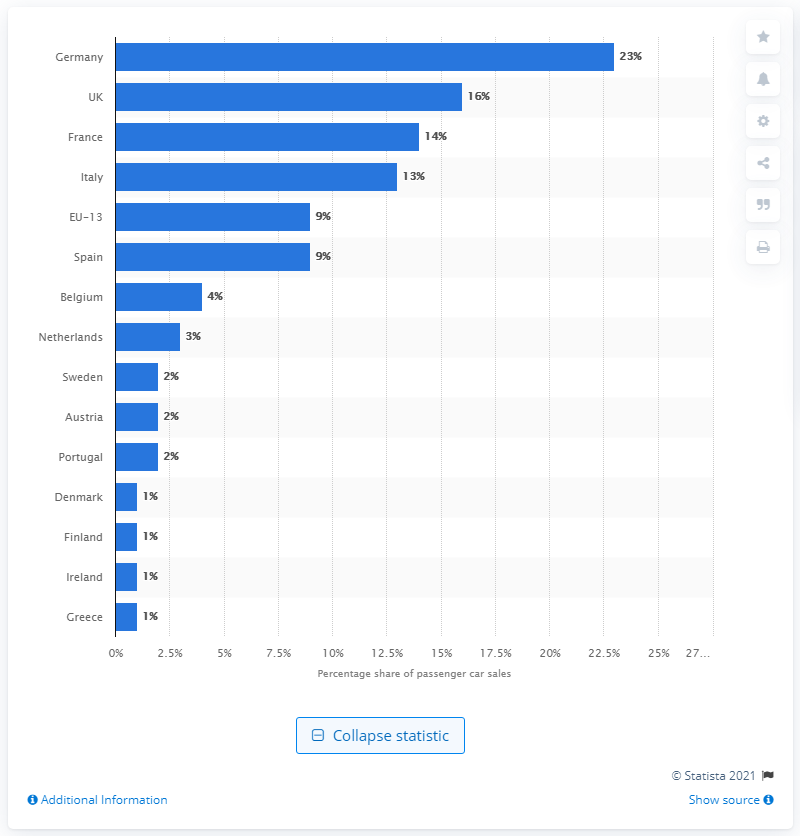Draw attention to some important aspects in this diagram. In 2018, nearly a quarter of all new passenger cars sold in the European Union were sold in Germany, making it the top market for car sales in the EU. 